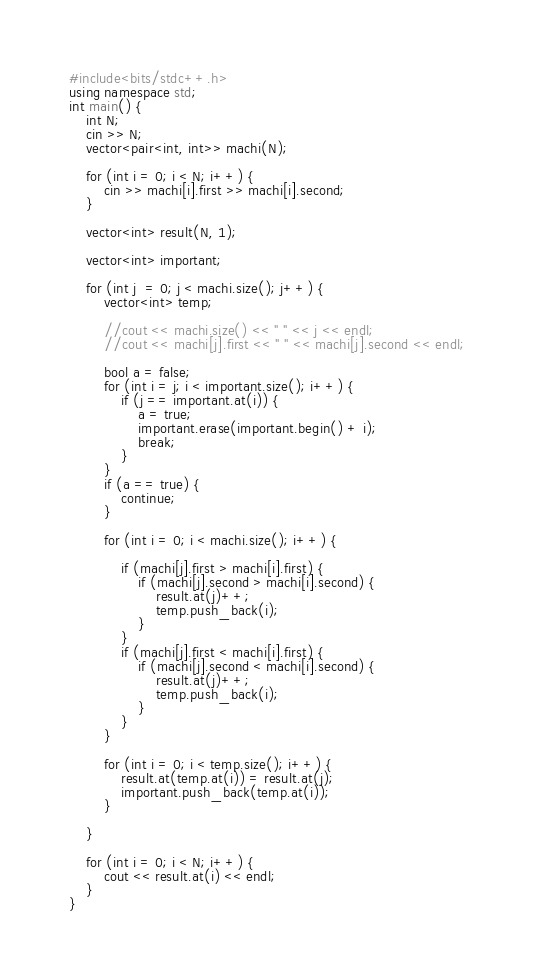Convert code to text. <code><loc_0><loc_0><loc_500><loc_500><_C++_>#include<bits/stdc++.h>
using namespace std;
int main() {
    int N;
    cin >> N;
    vector<pair<int, int>> machi(N);

    for (int i = 0; i < N; i++) {
        cin >> machi[i].first >> machi[i].second;
    }

    vector<int> result(N, 1);

    vector<int> important;

    for (int j  = 0; j < machi.size(); j++) {
        vector<int> temp;

        //cout << machi.size() << " " << j << endl;
        //cout << machi[j].first << " " << machi[j].second << endl;

        bool a = false;
        for (int i = j; i < important.size(); i++) {
            if (j == important.at(i)) {
                a = true;
                important.erase(important.begin() + i);
                break;
            }
        }
        if (a == true) {
            continue;
        }

        for (int i = 0; i < machi.size(); i++) {

            if (machi[j].first > machi[i].first) {
                if (machi[j].second > machi[i].second) {
                    result.at(j)++;
                    temp.push_back(i);
                }
            }
            if (machi[j].first < machi[i].first) {
                if (machi[j].second < machi[i].second) {
                    result.at(j)++;
                    temp.push_back(i);
                }
            }
        }

        for (int i = 0; i < temp.size(); i++) {
            result.at(temp.at(i)) = result.at(j);
            important.push_back(temp.at(i));
        }

    }

    for (int i = 0; i < N; i++) {
        cout << result.at(i) << endl;
    }
}</code> 